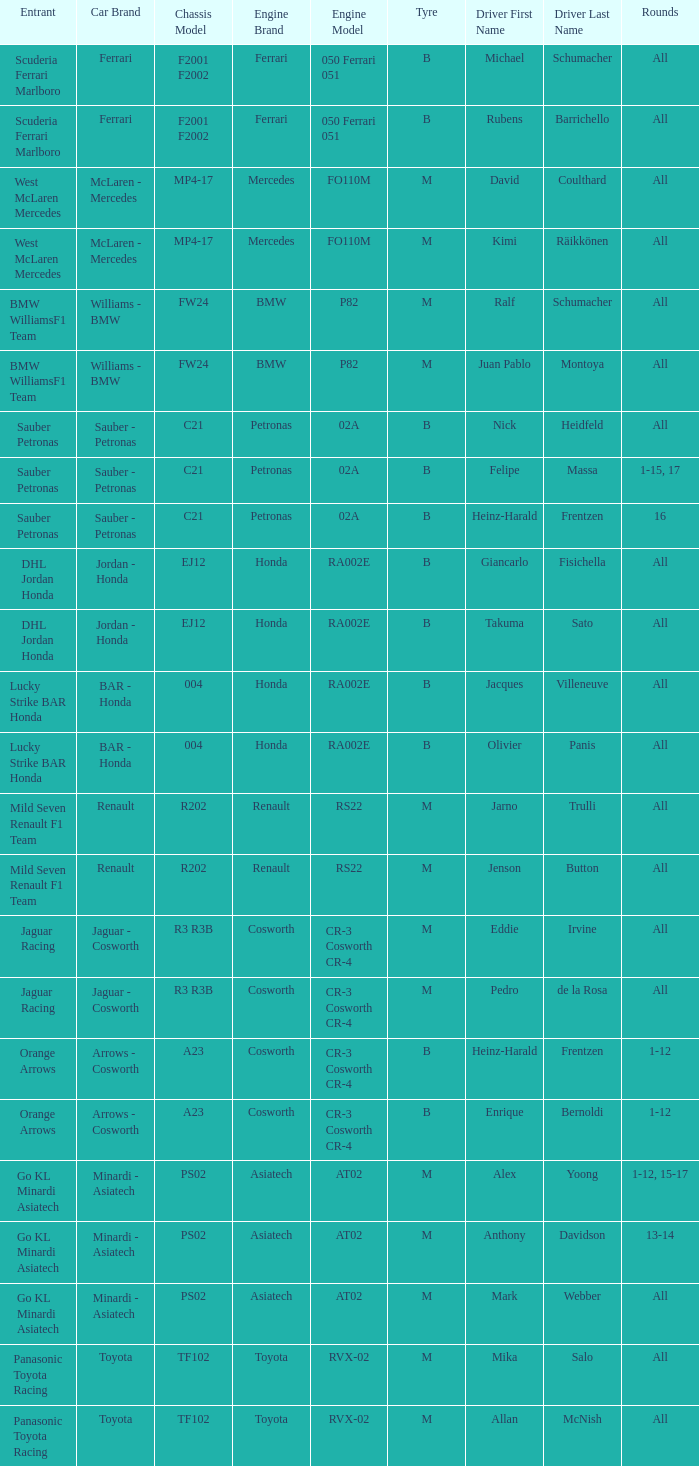What is the chassis when the tyre is b, the engine is ferrari 050 ferrari 051 and the driver is rubens barrichello? F2001 F2002. 